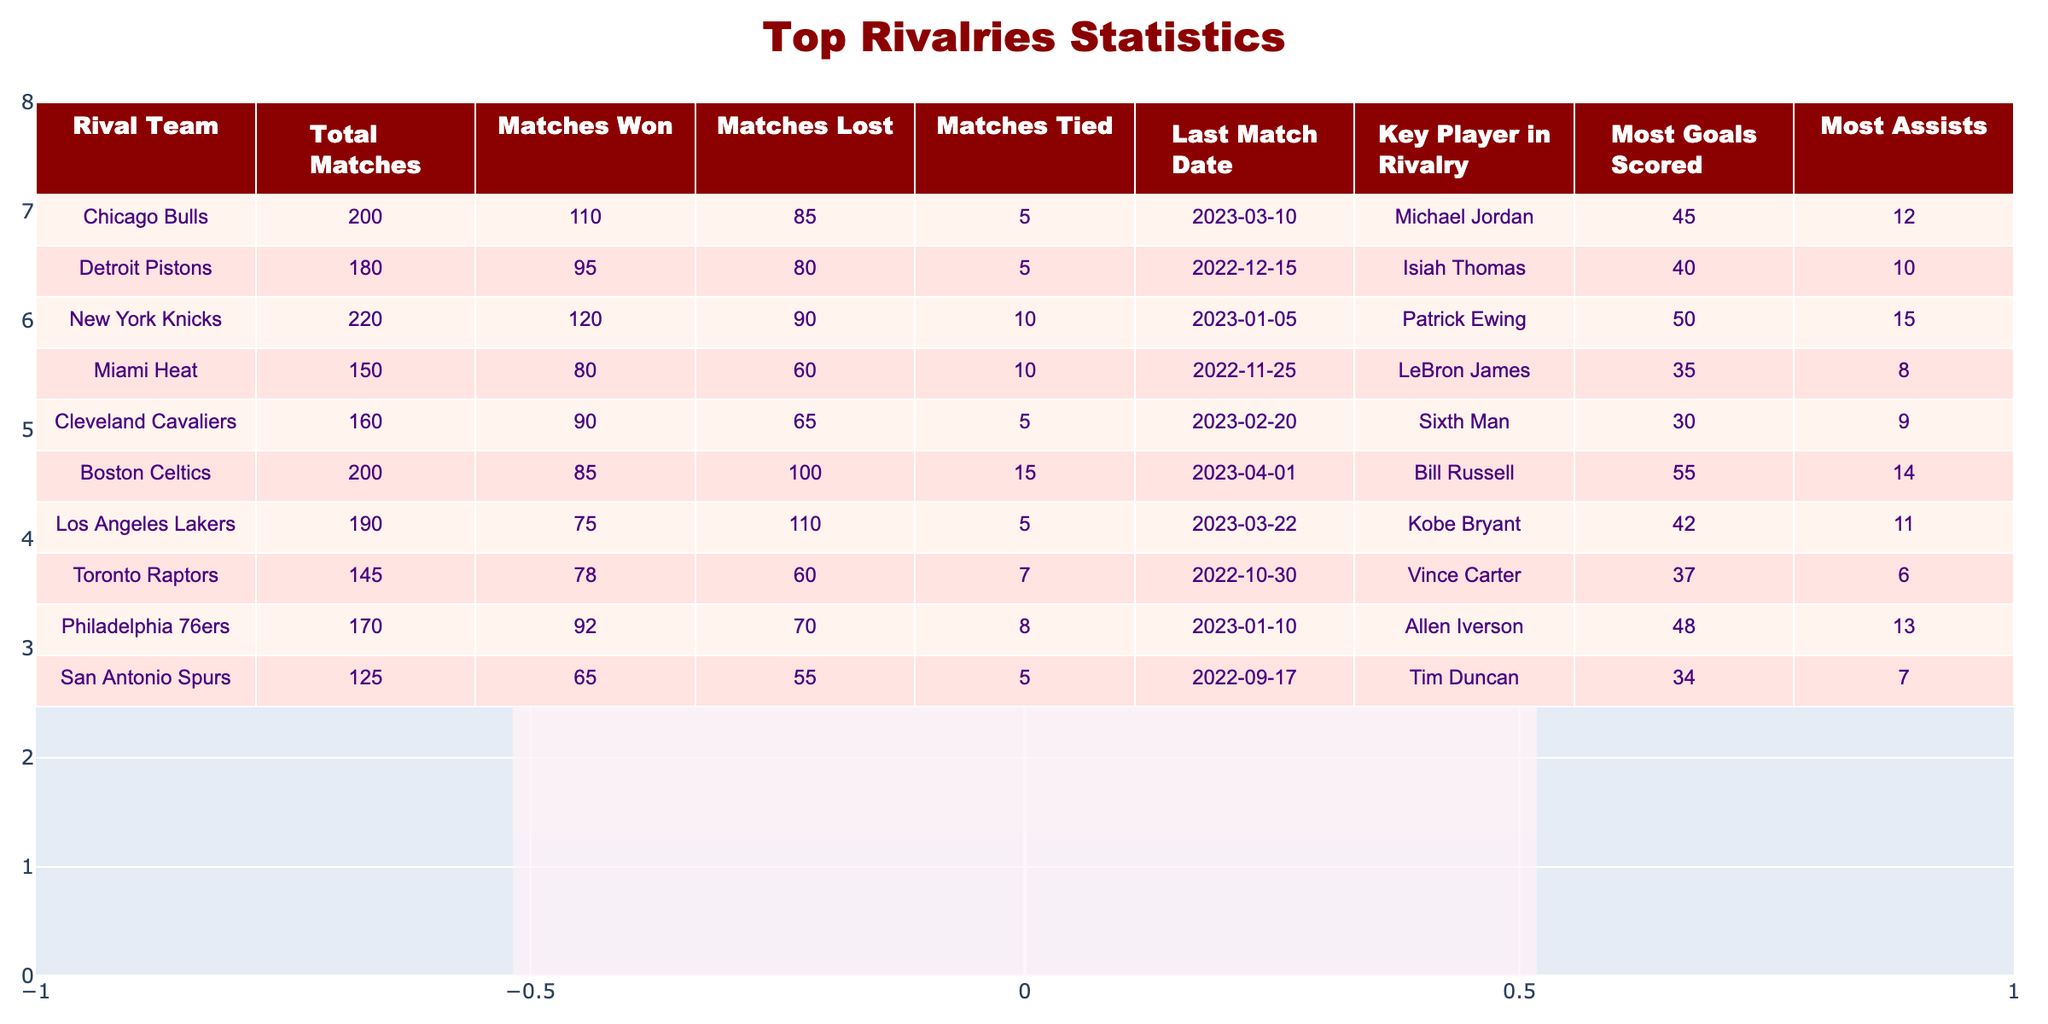What is the total number of matches played against the New York Knicks? The table lists a total of 220 matches played against the New York Knicks.
Answer: 220 Which rival team has the highest number of matches won? Upon reviewing the matches won statistics, the Chicago Bulls have the highest number with 110 wins.
Answer: Chicago Bulls How many goals did the player with the most goals scored against the Miami Heat score? The table shows that the most goals scored against the Miami Heat is 35, attributed to LeBron James.
Answer: 35 What is the difference in total matches played between the Boston Celtics and the Philadelphia 76ers? Boston Celtics played 200 matches and Philadelphia 76ers played 170 matches. Therefore, the difference is 200 - 170 = 30 matches.
Answer: 30 Did the Cleveland Cavaliers win more matches than they lost? The data shows that the Cleveland Cavaliers won 90 matches and lost 65. Since they won more matches than they lost, the statement is true.
Answer: Yes Which rival team had the most assists by a key player in rivalry? Upon checking the assists column, the New York Knicks had a key player, Patrick Ewing, who made a total of 15 assists, which is the highest among all listed teams.
Answer: New York Knicks What is the total number of ties across all rival teams? The total number of ties can be calculated by adding the tied matches for all teams. The values are: 5 (Bulls) + 5 (Pistons) + 10 (Knicks) + 10 (Heat) + 5 (Cavaliers) + 15 (Celtics) + 5 (Lakers) + 7 (Raptors) + 8 (76ers) + 5 (Spurs) = 70 ties in total.
Answer: 70 Which rival team has the closest number of matches won to the total matches played? Looking at the statistics, the Miami Heat played 150 matches and won 80, which gives a ratio of around 53.33%. This is closest to their total matches compared to the other rival teams listed.
Answer: Miami Heat Which team has the lowest number of wins? Reviewing the data, the Los Angeles Lakers have the lowest wins with only 75 matches won.
Answer: Los Angeles Lakers 